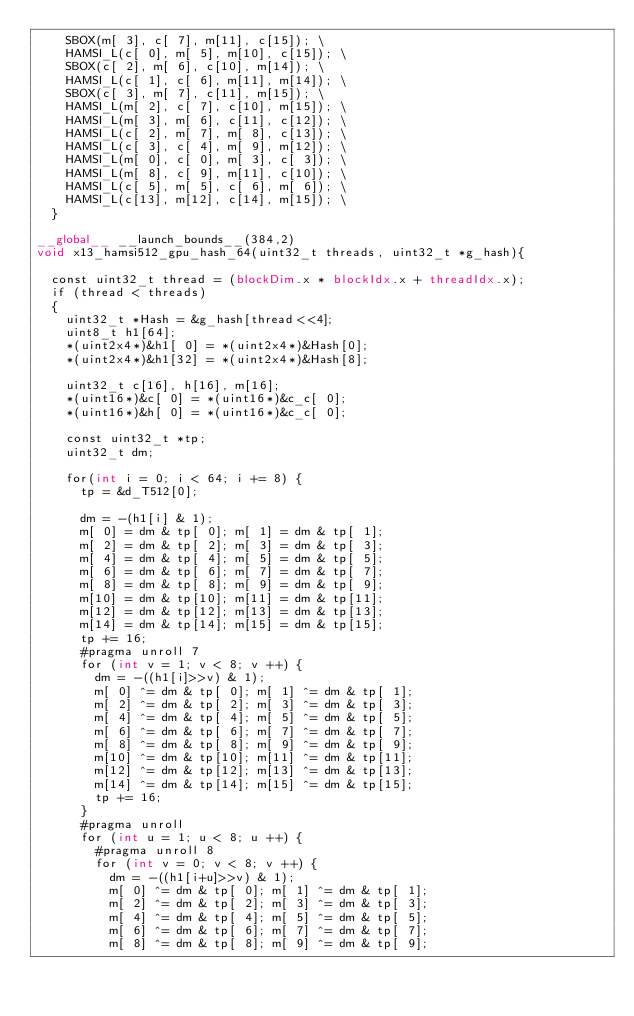<code> <loc_0><loc_0><loc_500><loc_500><_Cuda_>		SBOX(m[ 3], c[ 7], m[11], c[15]); \
		HAMSI_L(c[ 0], m[ 5], m[10], c[15]); \
		SBOX(c[ 2], m[ 6], c[10], m[14]); \
		HAMSI_L(c[ 1], c[ 6], m[11], m[14]); \
		SBOX(c[ 3], m[ 7], c[11], m[15]); \
		HAMSI_L(m[ 2], c[ 7], c[10], m[15]); \
		HAMSI_L(m[ 3], m[ 6], c[11], c[12]); \
		HAMSI_L(c[ 2], m[ 7], m[ 8], c[13]); \
		HAMSI_L(c[ 3], c[ 4], m[ 9], m[12]); \
		HAMSI_L(m[ 0], c[ 0], m[ 3], c[ 3]); \
		HAMSI_L(m[ 8], c[ 9], m[11], c[10]); \
		HAMSI_L(c[ 5], m[ 5], c[ 6], m[ 6]); \
		HAMSI_L(c[13], m[12], c[14], m[15]); \
	}

__global__ __launch_bounds__(384,2)
void x13_hamsi512_gpu_hash_64(uint32_t threads, uint32_t *g_hash){

	const uint32_t thread = (blockDim.x * blockIdx.x + threadIdx.x);
	if (thread < threads)
	{
		uint32_t *Hash = &g_hash[thread<<4];
		uint8_t h1[64];
		*(uint2x4*)&h1[ 0] = *(uint2x4*)&Hash[0];
		*(uint2x4*)&h1[32] = *(uint2x4*)&Hash[8];

		uint32_t c[16], h[16], m[16];
		*(uint16*)&c[ 0] = *(uint16*)&c_c[ 0];
		*(uint16*)&h[ 0] = *(uint16*)&c_c[ 0];

		const uint32_t *tp;
		uint32_t dm;

		for(int i = 0; i < 64; i += 8) {
			tp = &d_T512[0];

			dm = -(h1[i] & 1);
			m[ 0] = dm & tp[ 0]; m[ 1] = dm & tp[ 1];
			m[ 2] = dm & tp[ 2]; m[ 3] = dm & tp[ 3];
			m[ 4] = dm & tp[ 4]; m[ 5] = dm & tp[ 5];
			m[ 6] = dm & tp[ 6]; m[ 7] = dm & tp[ 7];
			m[ 8] = dm & tp[ 8]; m[ 9] = dm & tp[ 9];
			m[10] = dm & tp[10]; m[11] = dm & tp[11];
			m[12] = dm & tp[12]; m[13] = dm & tp[13];
			m[14] = dm & tp[14]; m[15] = dm & tp[15];
			tp += 16;
			#pragma unroll 7
			for (int v = 1; v < 8; v ++) {
				dm = -((h1[i]>>v) & 1);
				m[ 0] ^= dm & tp[ 0]; m[ 1] ^= dm & tp[ 1];
				m[ 2] ^= dm & tp[ 2]; m[ 3] ^= dm & tp[ 3];
				m[ 4] ^= dm & tp[ 4]; m[ 5] ^= dm & tp[ 5];
				m[ 6] ^= dm & tp[ 6]; m[ 7] ^= dm & tp[ 7];
				m[ 8] ^= dm & tp[ 8]; m[ 9] ^= dm & tp[ 9];
				m[10] ^= dm & tp[10]; m[11] ^= dm & tp[11];
				m[12] ^= dm & tp[12]; m[13] ^= dm & tp[13];
				m[14] ^= dm & tp[14]; m[15] ^= dm & tp[15];
				tp += 16;
			}
			#pragma unroll
			for (int u = 1; u < 8; u ++) {
				#pragma unroll 8
				for (int v = 0; v < 8; v ++) {
					dm = -((h1[i+u]>>v) & 1);
					m[ 0] ^= dm & tp[ 0]; m[ 1] ^= dm & tp[ 1];
					m[ 2] ^= dm & tp[ 2]; m[ 3] ^= dm & tp[ 3];
					m[ 4] ^= dm & tp[ 4]; m[ 5] ^= dm & tp[ 5];
					m[ 6] ^= dm & tp[ 6]; m[ 7] ^= dm & tp[ 7];
					m[ 8] ^= dm & tp[ 8]; m[ 9] ^= dm & tp[ 9];</code> 